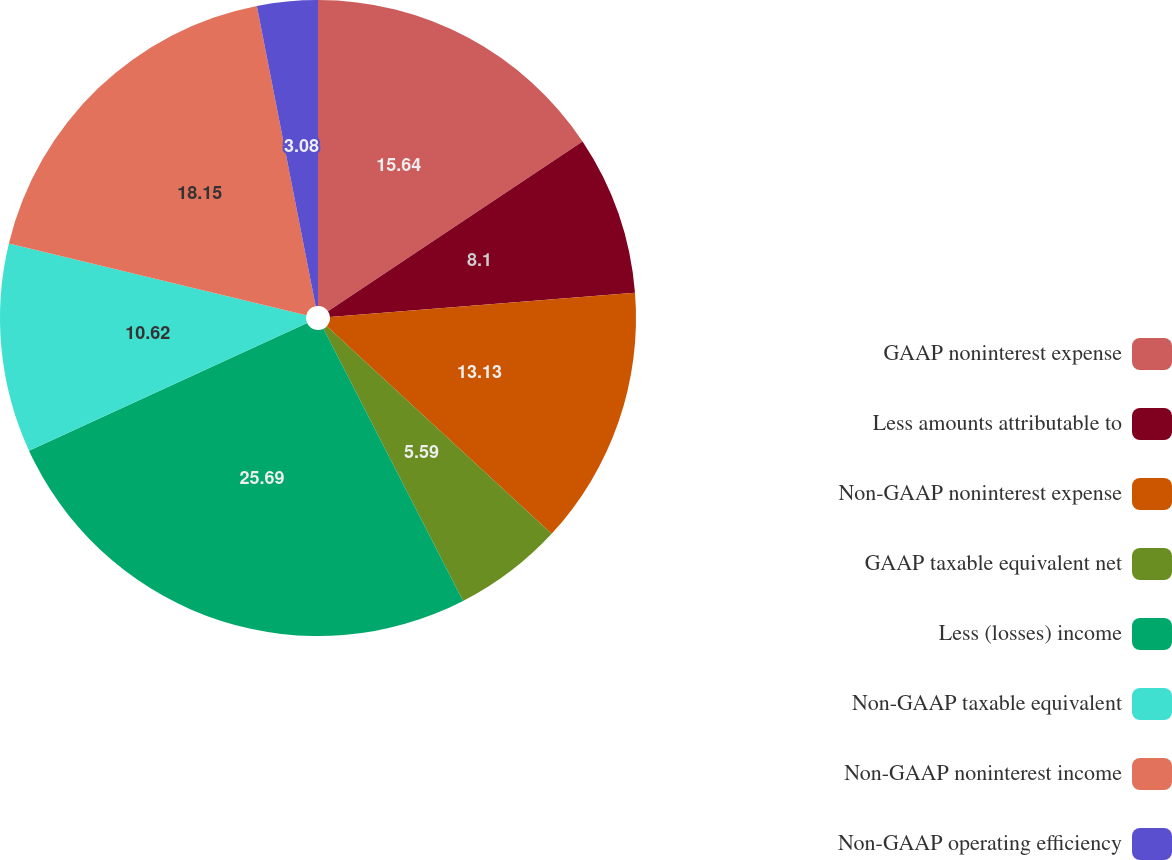Convert chart to OTSL. <chart><loc_0><loc_0><loc_500><loc_500><pie_chart><fcel>GAAP noninterest expense<fcel>Less amounts attributable to<fcel>Non-GAAP noninterest expense<fcel>GAAP taxable equivalent net<fcel>Less (losses) income<fcel>Non-GAAP taxable equivalent<fcel>Non-GAAP noninterest income<fcel>Non-GAAP operating efficiency<nl><fcel>15.64%<fcel>8.1%<fcel>13.13%<fcel>5.59%<fcel>25.69%<fcel>10.62%<fcel>18.15%<fcel>3.08%<nl></chart> 